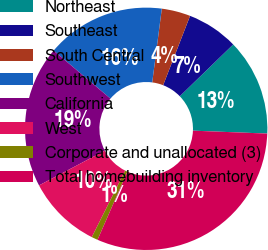Convert chart to OTSL. <chart><loc_0><loc_0><loc_500><loc_500><pie_chart><fcel>Northeast<fcel>Southeast<fcel>South Central<fcel>Southwest<fcel>California<fcel>West<fcel>Corporate and unallocated (3)<fcel>Total homebuilding inventory<nl><fcel>12.88%<fcel>6.85%<fcel>3.84%<fcel>15.89%<fcel>18.9%<fcel>9.86%<fcel>0.83%<fcel>30.95%<nl></chart> 